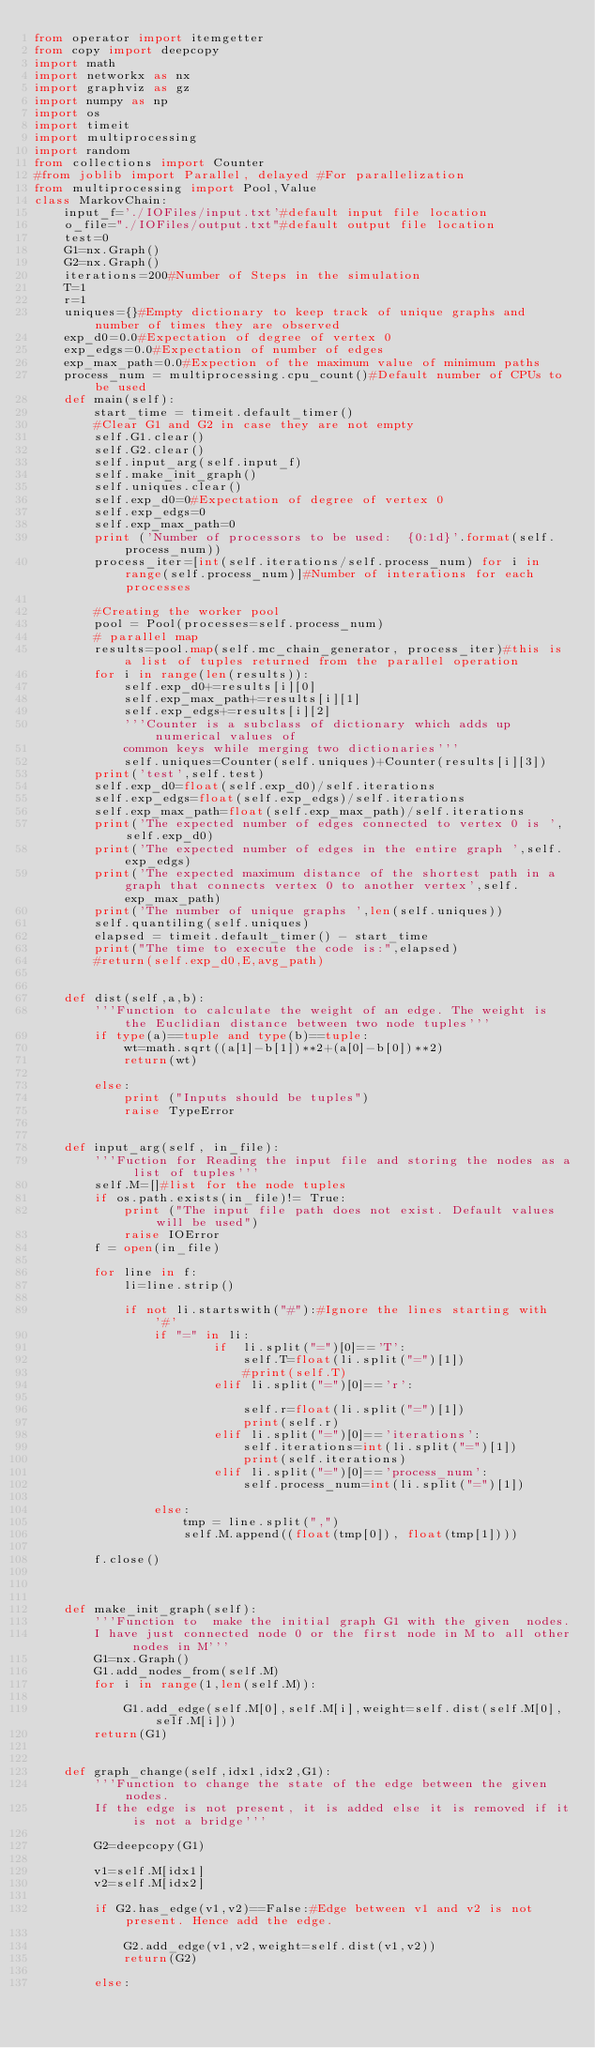Convert code to text. <code><loc_0><loc_0><loc_500><loc_500><_Python_>from operator import itemgetter
from copy import deepcopy
import math
import networkx as nx
import graphviz as gz
import numpy as np
import os
import timeit
import multiprocessing
import random
from collections import Counter
#from joblib import Parallel, delayed #For parallelization
from multiprocessing import Pool,Value
class MarkovChain:
    input_f='./IOFiles/input.txt'#default input file location
    o_file="./IOFiles/output.txt"#default output file location
    test=0
    G1=nx.Graph()
    G2=nx.Graph()
    iterations=200#Number of Steps in the simulation
    T=1
    r=1
    uniques={}#Empty dictionary to keep track of unique graphs and number of times they are observed
    exp_d0=0.0#Expectation of degree of vertex 0
    exp_edgs=0.0#Expectation of number of edges
    exp_max_path=0.0#Expection of the maximum value of minimum paths
    process_num = multiprocessing.cpu_count()#Default number of CPUs to be used
    def main(self):
        start_time = timeit.default_timer()
        #Clear G1 and G2 in case they are not empty
        self.G1.clear()
        self.G2.clear()
        self.input_arg(self.input_f)
        self.make_init_graph()
        self.uniques.clear()
        self.exp_d0=0#Expectation of degree of vertex 0
        self.exp_edgs=0
        self.exp_max_path=0
        print ('Number of processors to be used:  {0:1d}'.format(self.process_num))
        process_iter=[int(self.iterations/self.process_num) for i in range(self.process_num)]#Number of interations for each processes
        
        #Creating the worker pool
        pool = Pool(processes=self.process_num)   
        # parallel map
        results=pool.map(self.mc_chain_generator, process_iter)#this is a list of tuples returned from the parallel operation
        for i in range(len(results)):
            self.exp_d0+=results[i][0]
            self.exp_max_path+=results[i][1]
            self.exp_edgs+=results[i][2]
            '''Counter is a subclass of dictionary which adds up numerical values of 
            common keys while merging two dictionaries'''
            self.uniques=Counter(self.uniques)+Counter(results[i][3])
        print('test',self.test)
        self.exp_d0=float(self.exp_d0)/self.iterations
        self.exp_edgs=float(self.exp_edgs)/self.iterations
        self.exp_max_path=float(self.exp_max_path)/self.iterations
        print('The expected number of edges connected to vertex 0 is ',self.exp_d0)
        print('The expected number of edges in the entire graph ',self.exp_edgs)
        print('The expected maximum distance of the shortest path in a graph that connects vertex 0 to another vertex',self.exp_max_path)
        print('The number of unique graphs ',len(self.uniques))
        self.quantiling(self.uniques)
        elapsed = timeit.default_timer() - start_time
        print("The time to execute the code is:",elapsed)
        #return(self.exp_d0,E,avg_path)
    
   
    def dist(self,a,b):
        '''Function to calculate the weight of an edge. The weight is the Euclidian distance between two node tuples'''
        if type(a)==tuple and type(b)==tuple:
            wt=math.sqrt((a[1]-b[1])**2+(a[0]-b[0])**2)
            return(wt)

        else:
            print ("Inputs should be tuples")
            raise TypeError

        
    def input_arg(self, in_file):
        '''Fuction for Reading the input file and storing the nodes as a list of tuples''' 
        self.M=[]#list for the node tuples
        if os.path.exists(in_file)!= True:
            print ("The input file path does not exist. Default values will be used")
            raise IOError
        f = open(in_file)

        for line in f:
            li=line.strip()
   
            if not li.startswith("#"):#Ignore the lines starting with '#'
                if "=" in li:
                        if  li.split("=")[0]=='T':
                            self.T=float(li.split("=")[1])
                            #print(self.T)
                        elif li.split("=")[0]=='r':
                            
                            self.r=float(li.split("=")[1])
                            print(self.r)
                        elif li.split("=")[0]=='iterations':
                            self.iterations=int(li.split("=")[1])
                            print(self.iterations)
                        elif li.split("=")[0]=='process_num':
                            self.process_num=int(li.split("=")[1])

                else:
                    tmp = line.split(",")
                    self.M.append((float(tmp[0]), float(tmp[1])))
        
        f.close()

        
    
    def make_init_graph(self):
        '''Function to  make the initial graph G1 with the given  nodes. 
        I have just connected node 0 or the first node in M to all other nodes in M'''
        G1=nx.Graph()
        G1.add_nodes_from(self.M)
        for i in range(1,len(self.M)):
            
            G1.add_edge(self.M[0],self.M[i],weight=self.dist(self.M[0],self.M[i]))
        return(G1)
       
   
    def graph_change(self,idx1,idx2,G1):
        '''Function to change the state of the edge between the given nodes. 
        If the edge is not present, it is added else it is removed if it is not a bridge'''

        G2=deepcopy(G1)
        
        v1=self.M[idx1]
        v2=self.M[idx2]
        
        if G2.has_edge(v1,v2)==False:#Edge between v1 and v2 is not present. Hence add the edge.
            
            G2.add_edge(v1,v2,weight=self.dist(v1,v2))
            return(G2)
        
        else:</code> 